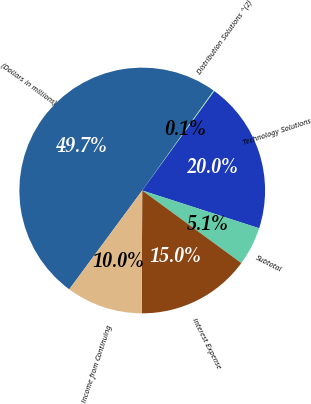Convert chart. <chart><loc_0><loc_0><loc_500><loc_500><pie_chart><fcel>(Dollars in millions)<fcel>Distribution Solutions ^(2)<fcel>Technology Solutions<fcel>Subtotal<fcel>Interest Expense<fcel>Income from Continuing<nl><fcel>49.75%<fcel>0.12%<fcel>19.98%<fcel>5.09%<fcel>15.01%<fcel>10.05%<nl></chart> 